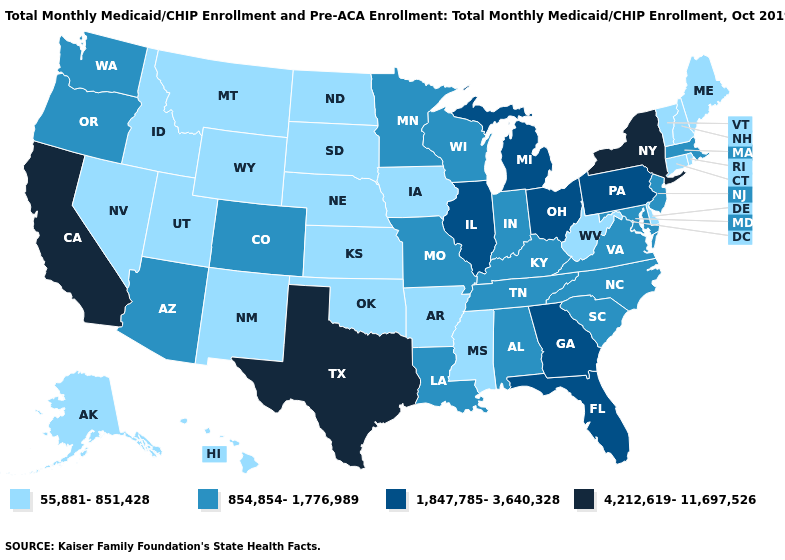What is the lowest value in states that border Montana?
Answer briefly. 55,881-851,428. How many symbols are there in the legend?
Give a very brief answer. 4. Does New York have the highest value in the USA?
Write a very short answer. Yes. What is the value of Virginia?
Keep it brief. 854,854-1,776,989. Name the states that have a value in the range 1,847,785-3,640,328?
Give a very brief answer. Florida, Georgia, Illinois, Michigan, Ohio, Pennsylvania. Among the states that border New Jersey , does Pennsylvania have the highest value?
Answer briefly. No. Name the states that have a value in the range 854,854-1,776,989?
Keep it brief. Alabama, Arizona, Colorado, Indiana, Kentucky, Louisiana, Maryland, Massachusetts, Minnesota, Missouri, New Jersey, North Carolina, Oregon, South Carolina, Tennessee, Virginia, Washington, Wisconsin. Which states have the lowest value in the West?
Answer briefly. Alaska, Hawaii, Idaho, Montana, Nevada, New Mexico, Utah, Wyoming. What is the lowest value in the USA?
Short answer required. 55,881-851,428. What is the value of Michigan?
Quick response, please. 1,847,785-3,640,328. Name the states that have a value in the range 1,847,785-3,640,328?
Be succinct. Florida, Georgia, Illinois, Michigan, Ohio, Pennsylvania. Does Washington have a higher value than Texas?
Concise answer only. No. What is the lowest value in states that border Indiana?
Answer briefly. 854,854-1,776,989. Name the states that have a value in the range 55,881-851,428?
Quick response, please. Alaska, Arkansas, Connecticut, Delaware, Hawaii, Idaho, Iowa, Kansas, Maine, Mississippi, Montana, Nebraska, Nevada, New Hampshire, New Mexico, North Dakota, Oklahoma, Rhode Island, South Dakota, Utah, Vermont, West Virginia, Wyoming. Does the map have missing data?
Short answer required. No. 